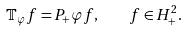<formula> <loc_0><loc_0><loc_500><loc_500>\mathbb { T } _ { \varphi } f = P _ { + } \varphi f , \quad f \in H _ { + } ^ { 2 } .</formula> 